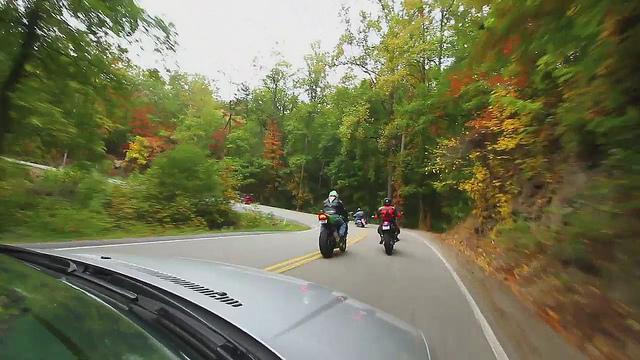Based on the position of the car, is the road in the United States or Europe?
Concise answer only. United states. How many people are on the road?
Answer briefly. 4. What pattern is the center line?
Write a very short answer. Straight. 